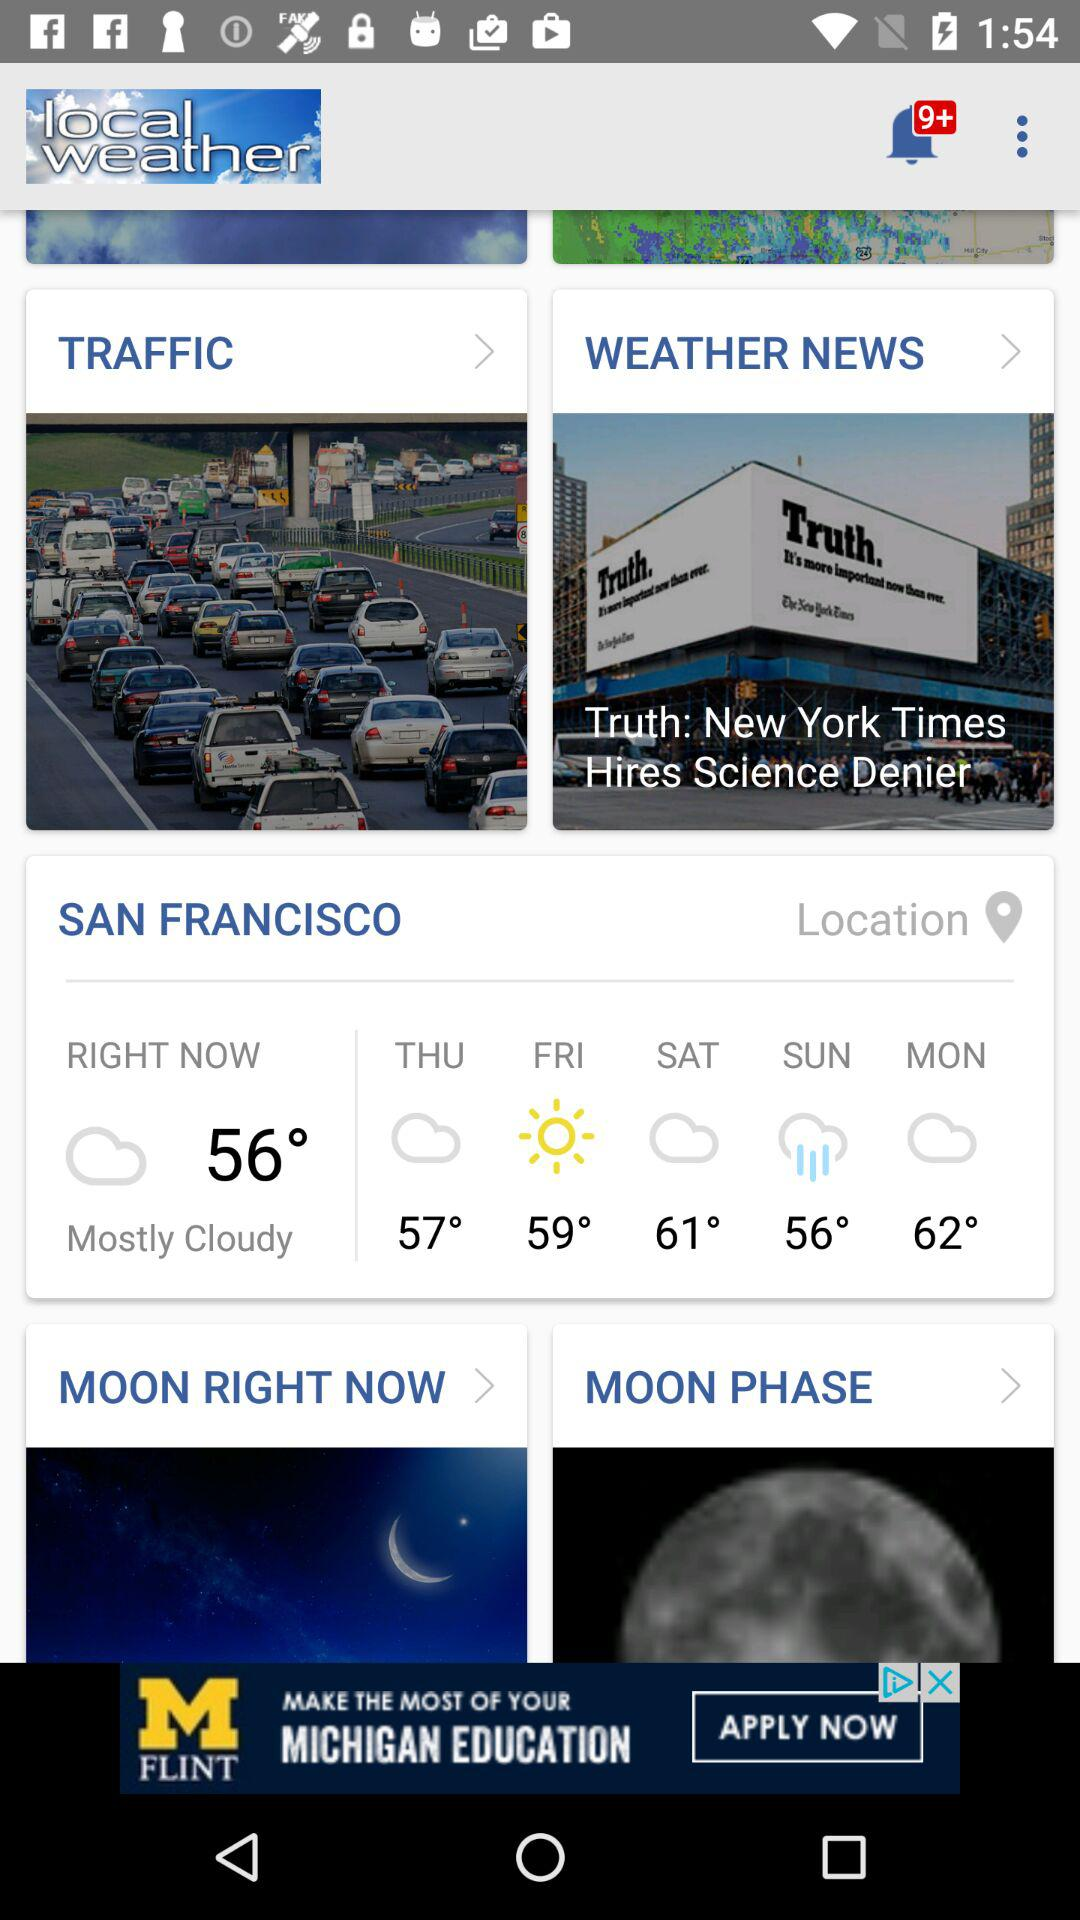How’s the weather on Sunday? The weather on Sunday is rainy. 